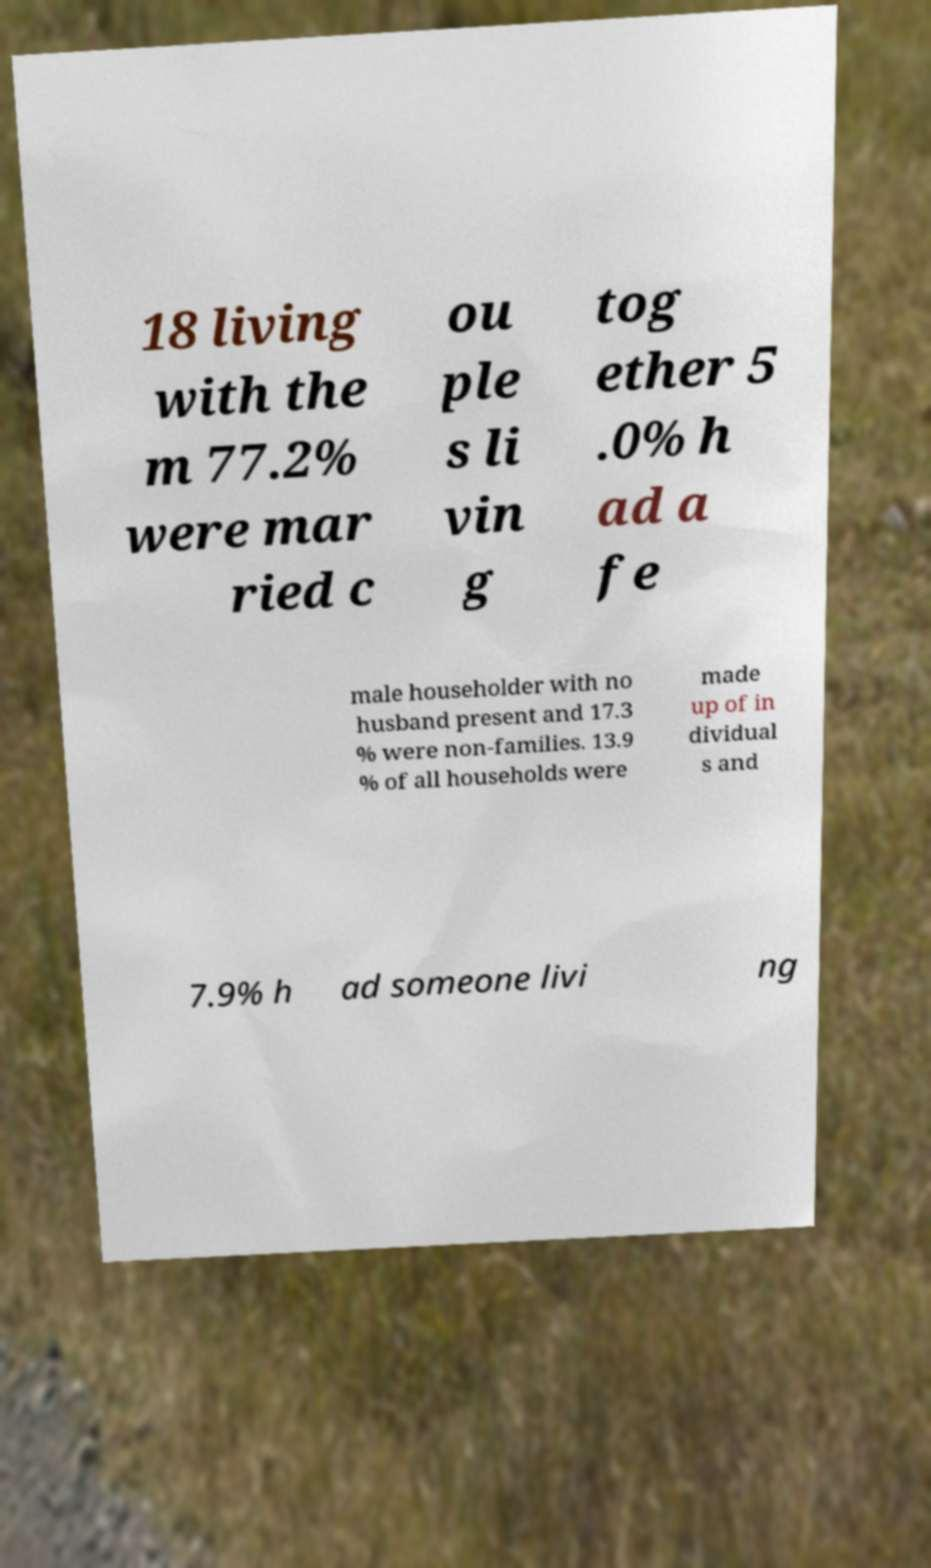I need the written content from this picture converted into text. Can you do that? 18 living with the m 77.2% were mar ried c ou ple s li vin g tog ether 5 .0% h ad a fe male householder with no husband present and 17.3 % were non-families. 13.9 % of all households were made up of in dividual s and 7.9% h ad someone livi ng 